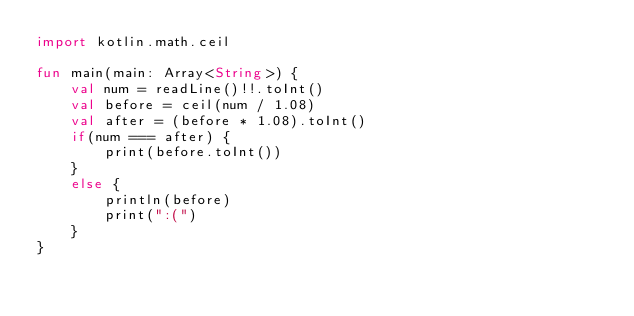Convert code to text. <code><loc_0><loc_0><loc_500><loc_500><_Kotlin_>import kotlin.math.ceil

fun main(main: Array<String>) {
    val num = readLine()!!.toInt()
    val before = ceil(num / 1.08)
    val after = (before * 1.08).toInt()
    if(num === after) {
        print(before.toInt())
    }
    else {
        println(before)
        print(":(")
    }
}</code> 